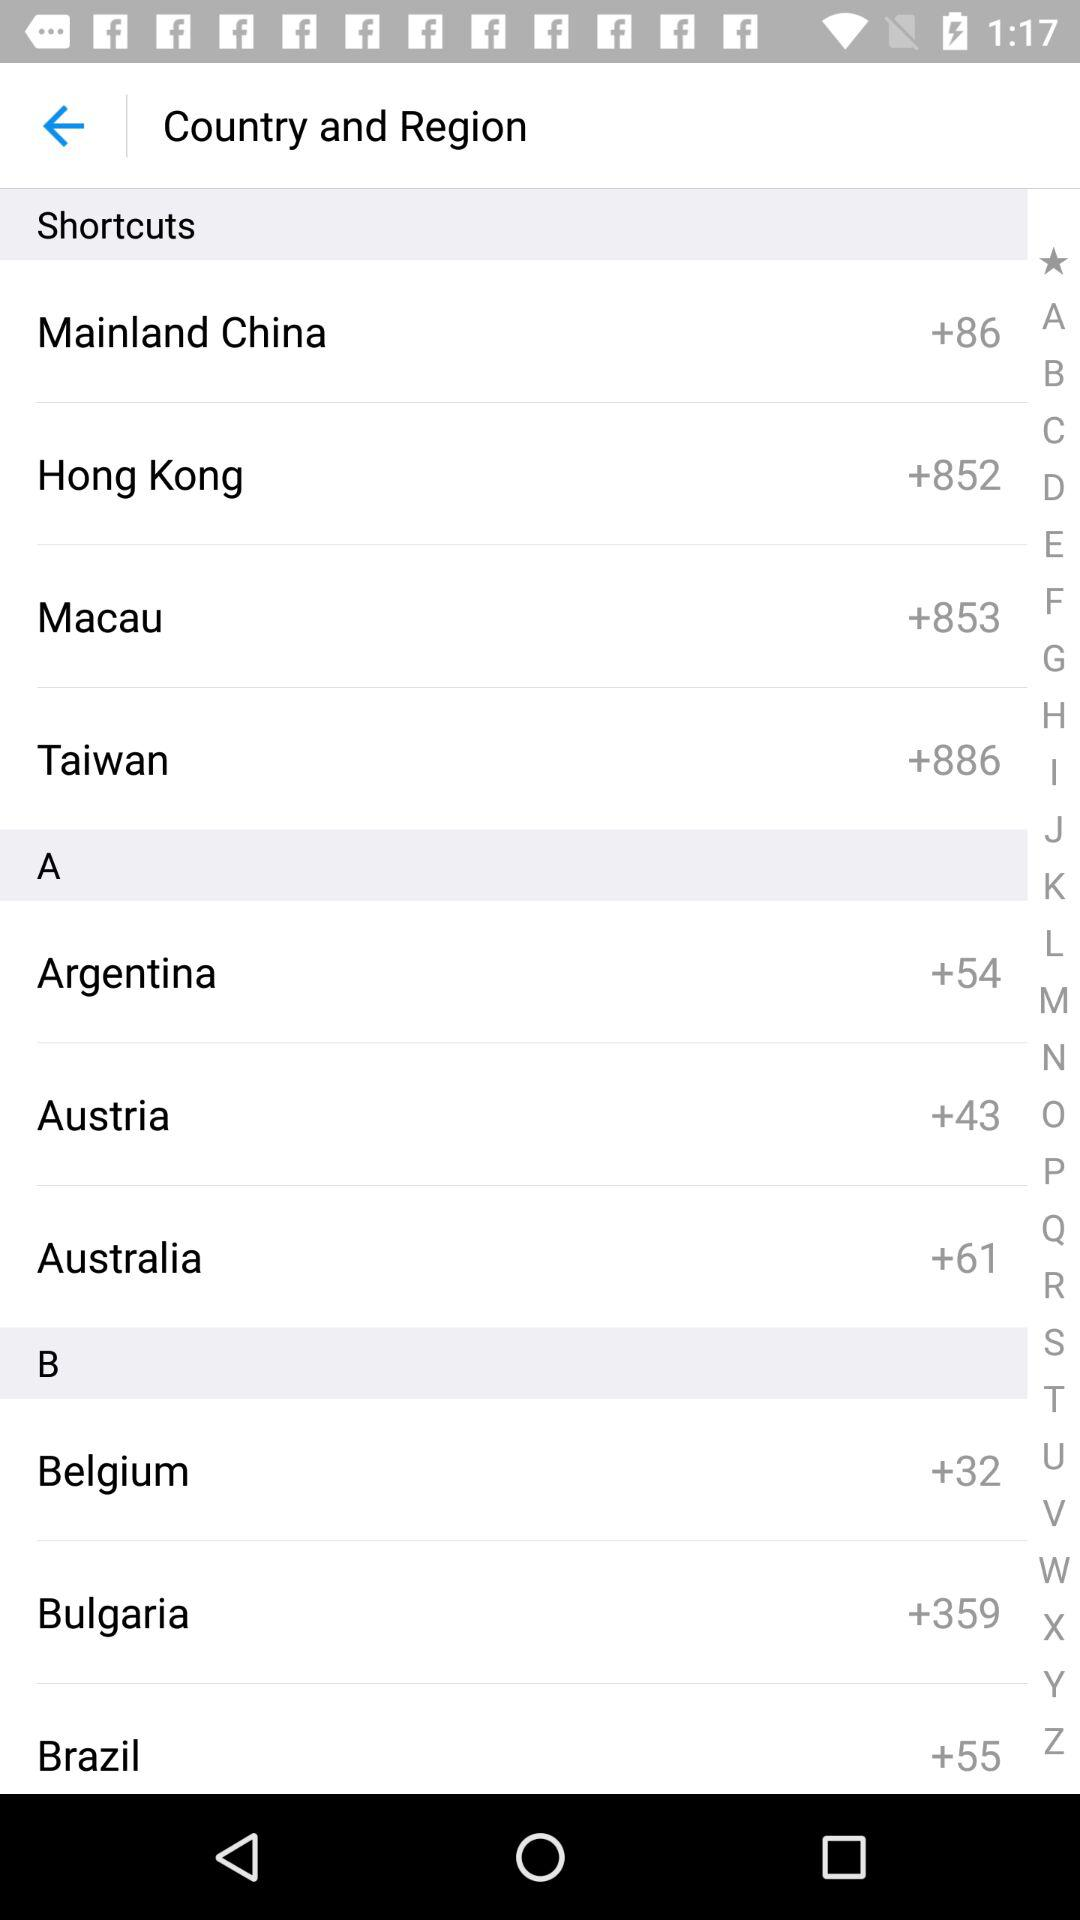Which countries are in the shortcut options? The countries are Mainland China, Hong Kong, Macau and Taiwan. 